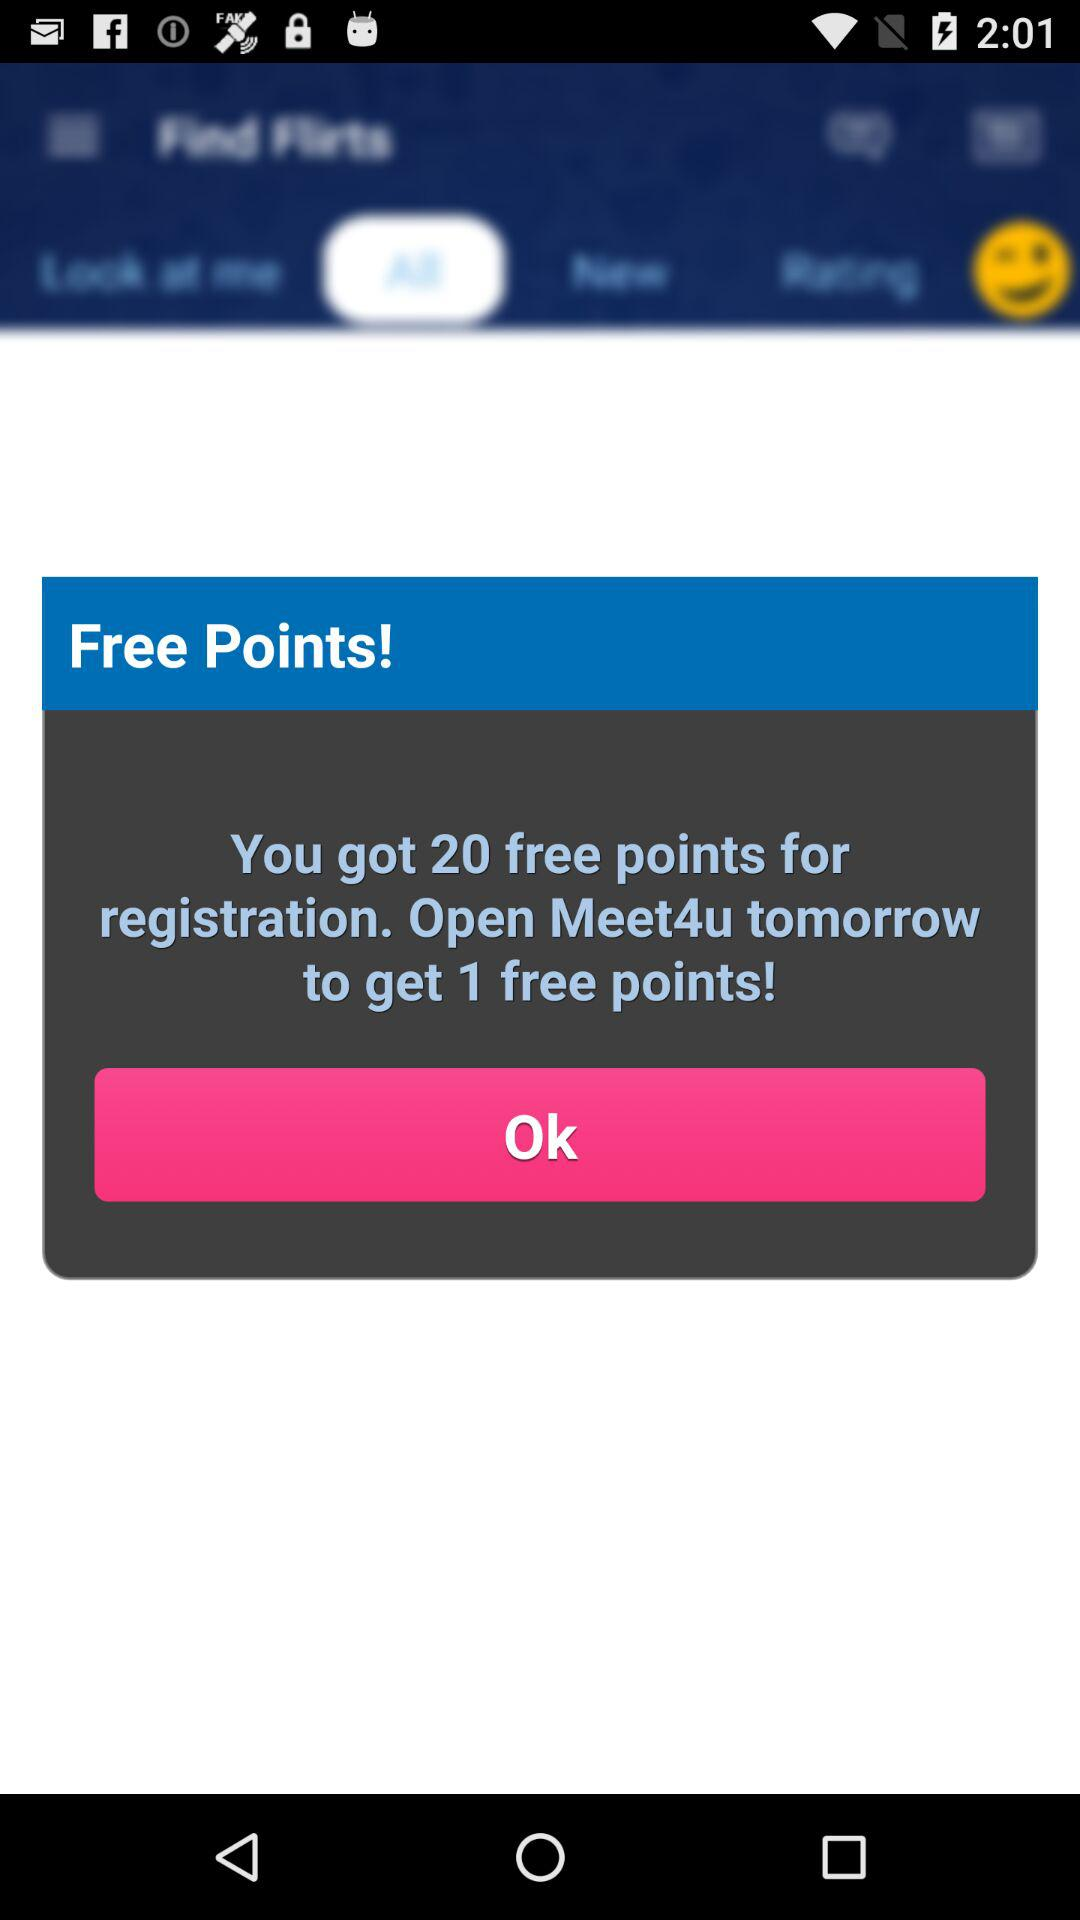How many free points can be earned by opening "Meet4u"? By opening "Meet4u", one free point can be earned. 